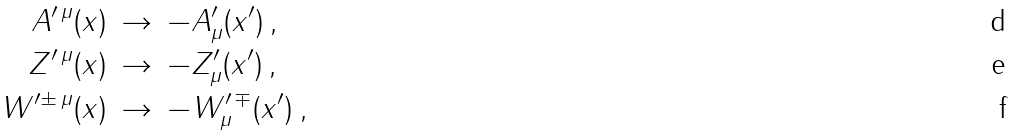Convert formula to latex. <formula><loc_0><loc_0><loc_500><loc_500>A ^ { \prime \, \mu } ( x ) \, & \rightarrow \, - A ^ { \prime } _ { \mu } ( x ^ { \prime } ) \, , \\ Z ^ { \prime \, \mu } ( x ) \, & \rightarrow \, - Z ^ { \prime } _ { \mu } ( x ^ { \prime } ) \, , \\ W ^ { \prime \pm \, \mu } ( x ) \, & \rightarrow \, - W ^ { \prime \, \mp } _ { \mu } ( x ^ { \prime } ) \, ,</formula> 